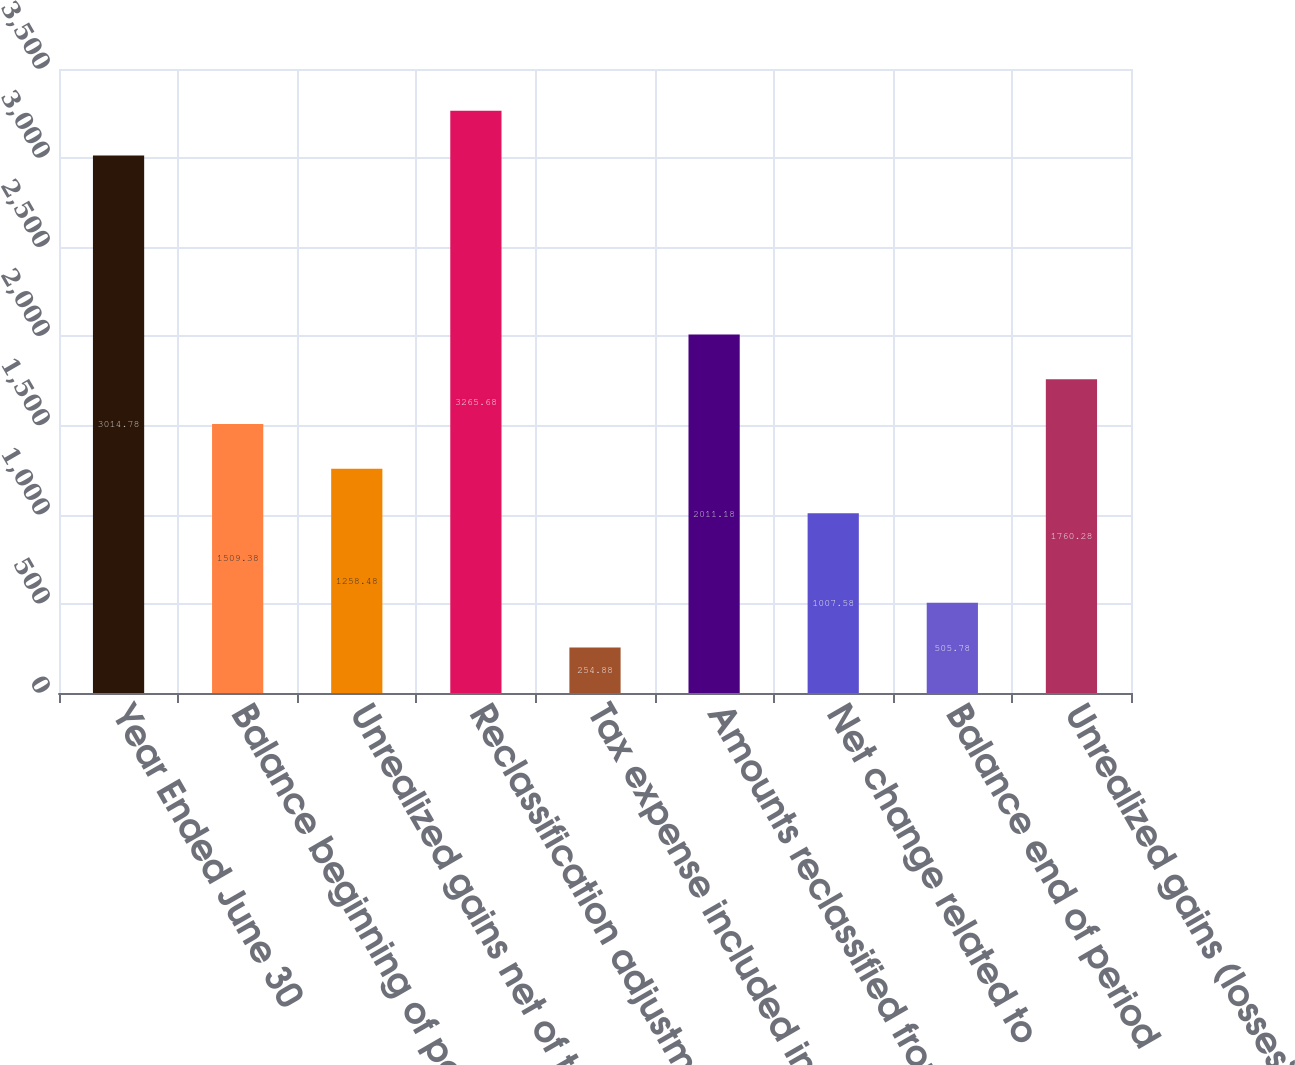<chart> <loc_0><loc_0><loc_500><loc_500><bar_chart><fcel>Year Ended June 30<fcel>Balance beginning of period<fcel>Unrealized gains net of tax of<fcel>Reclassification adjustments<fcel>Tax expense included in<fcel>Amounts reclassified from<fcel>Net change related to<fcel>Balance end of period<fcel>Unrealized gains (losses) net<nl><fcel>3014.78<fcel>1509.38<fcel>1258.48<fcel>3265.68<fcel>254.88<fcel>2011.18<fcel>1007.58<fcel>505.78<fcel>1760.28<nl></chart> 